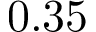<formula> <loc_0><loc_0><loc_500><loc_500>0 . 3 5</formula> 